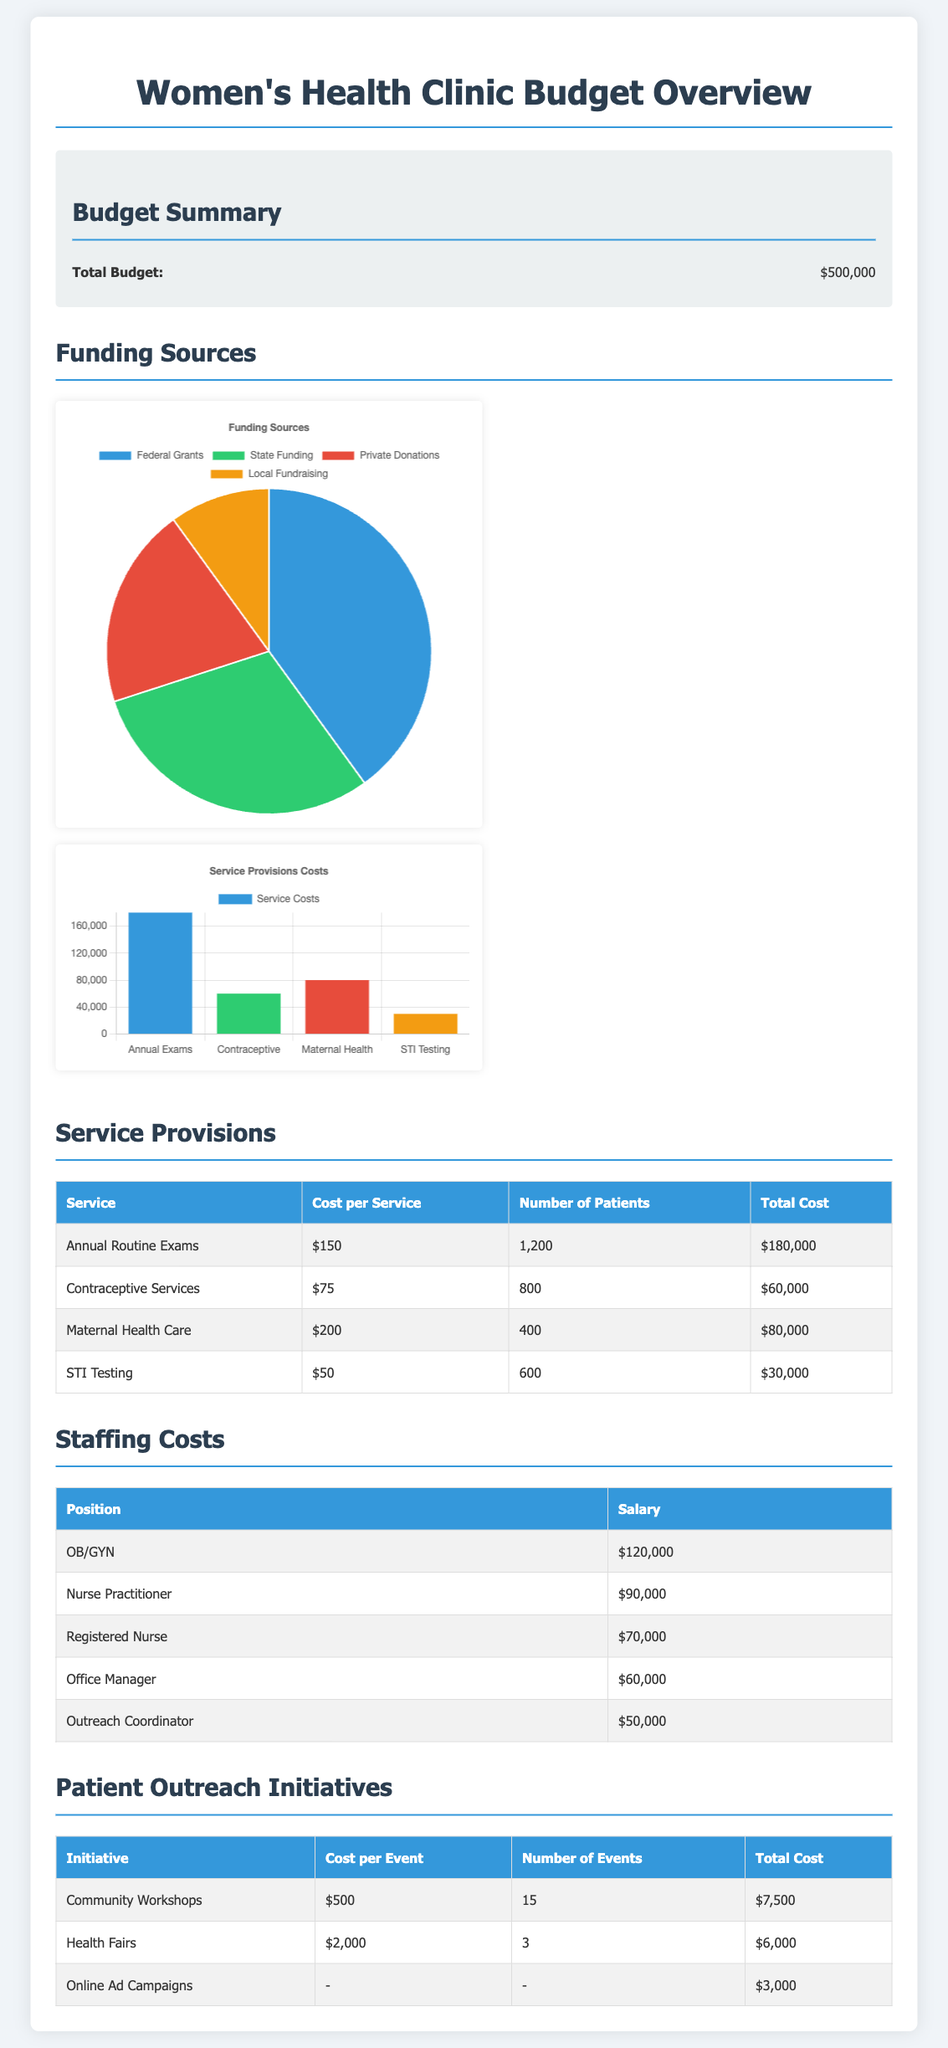What is the total budget? The total budget is clearly stated at the top of the budget summary section in the document.
Answer: $500,000 How many patients are served for Annual Routine Exams? The number of patients for Annual Routine Exams is listed in the service provisions table.
Answer: 1,200 What is the cost per service for Contraceptive Services? The cost per service for Contraceptive Services can be found in the service provisions table.
Answer: $75 What position has the highest salary? The position with the highest salary is indicated in the staffing costs table.
Answer: OB/GYN How much is allocated for Online Ad Campaigns? The total cost for Online Ad Campaigns is provided in the patient outreach initiatives table.
Answer: $3,000 What is the total cost for Maternal Health Care? The total cost for Maternal Health Care is detailed in the service provisions table.
Answer: $80,000 How many community workshops are planned? The planned number of community workshops is listed in the patient outreach initiatives section.
Answer: 15 What is the total cost for staffing? The staffing costs would require summing the salaries listed for each position in the staffing costs table.
Answer: $430,000 Which funding source is the highest? The funding sources chart indicates which source contributes the largest amount to the budget.
Answer: Federal Grants 